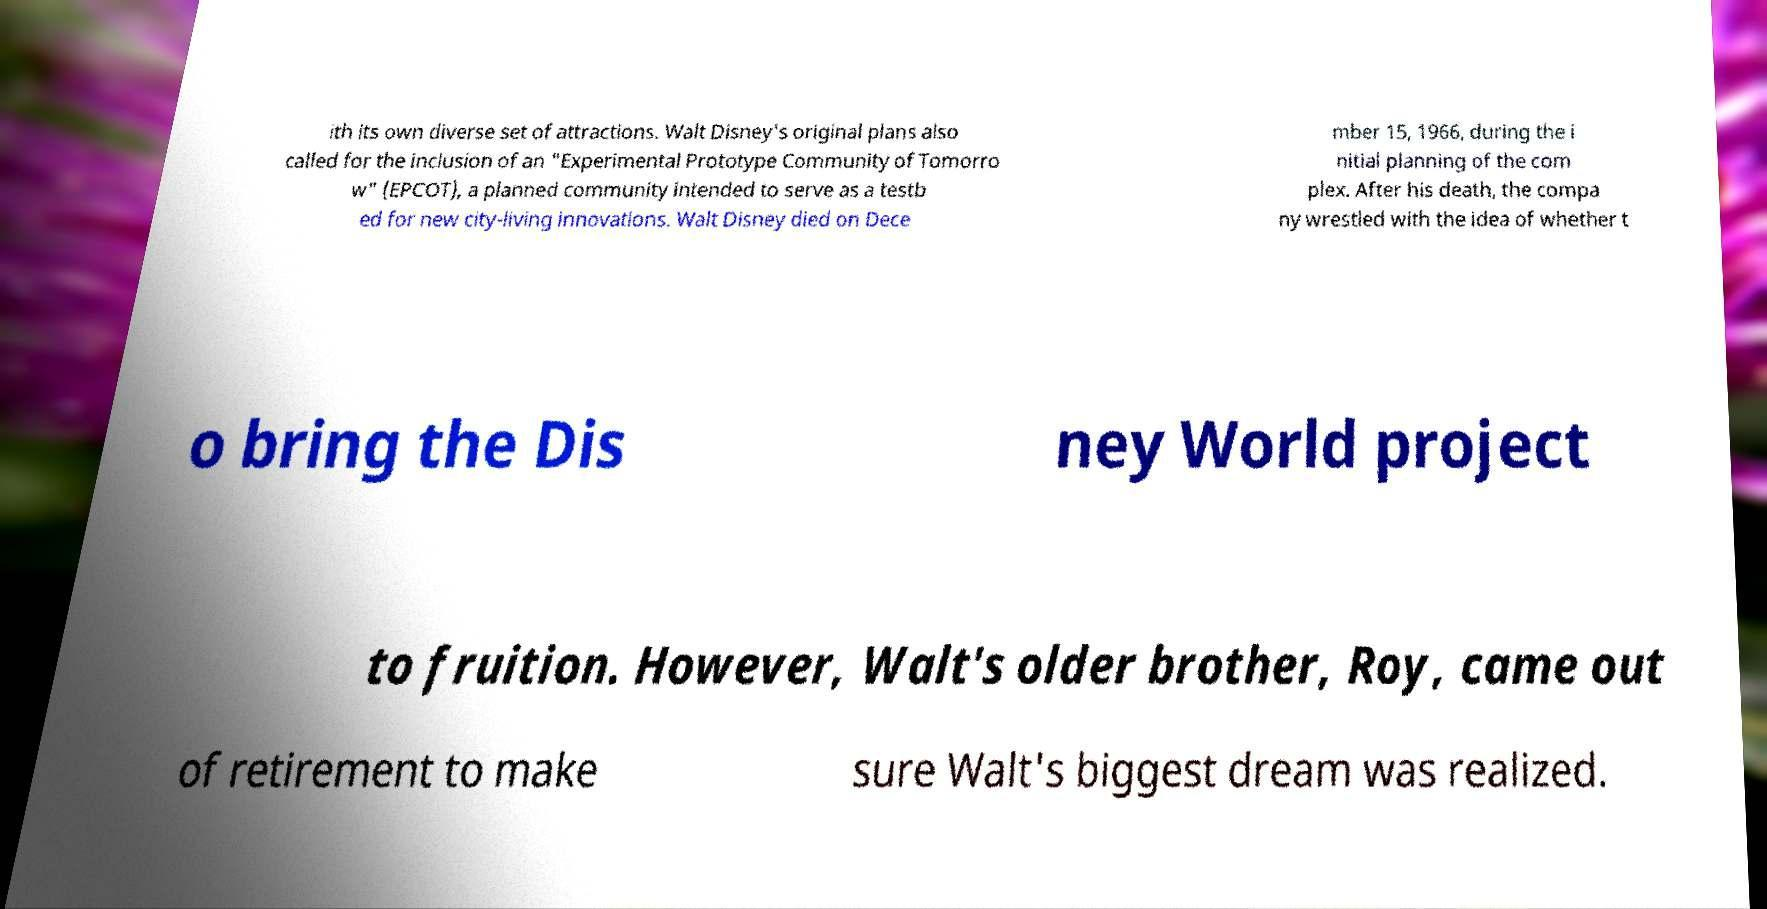Can you read and provide the text displayed in the image?This photo seems to have some interesting text. Can you extract and type it out for me? ith its own diverse set of attractions. Walt Disney's original plans also called for the inclusion of an "Experimental Prototype Community of Tomorro w" (EPCOT), a planned community intended to serve as a testb ed for new city-living innovations. Walt Disney died on Dece mber 15, 1966, during the i nitial planning of the com plex. After his death, the compa ny wrestled with the idea of whether t o bring the Dis ney World project to fruition. However, Walt's older brother, Roy, came out of retirement to make sure Walt's biggest dream was realized. 